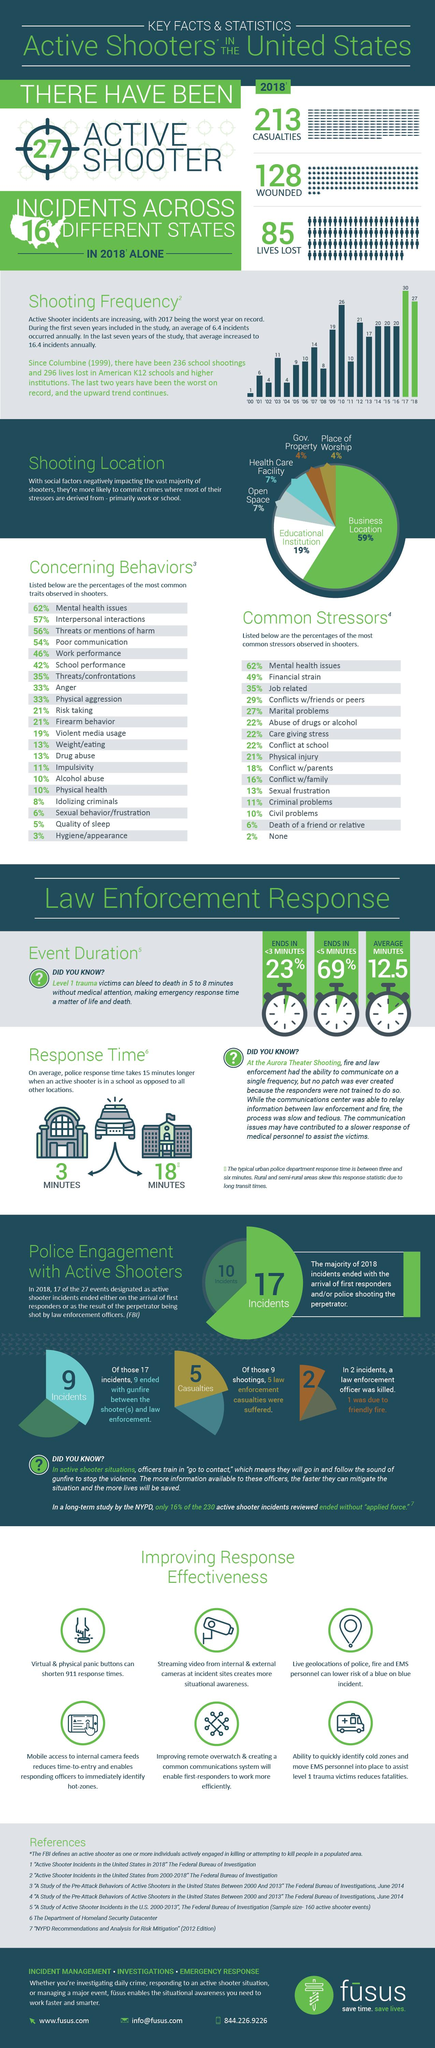Draw attention to some important aspects in this diagram. The study found that anger and physical aggression played a significant role in the development of shooting traits, contributing 33% to the overall score. According to the survey, conflict at school and abuse of drugs or alcohol were identified as significant stressors, contributing to 22% of the respondents' overall stress levels. Quality of sleep is the second lowest concerning behavior, Financial strain is the second highest common stressors. The year in which the shooting frequency was the third highest was '10. 